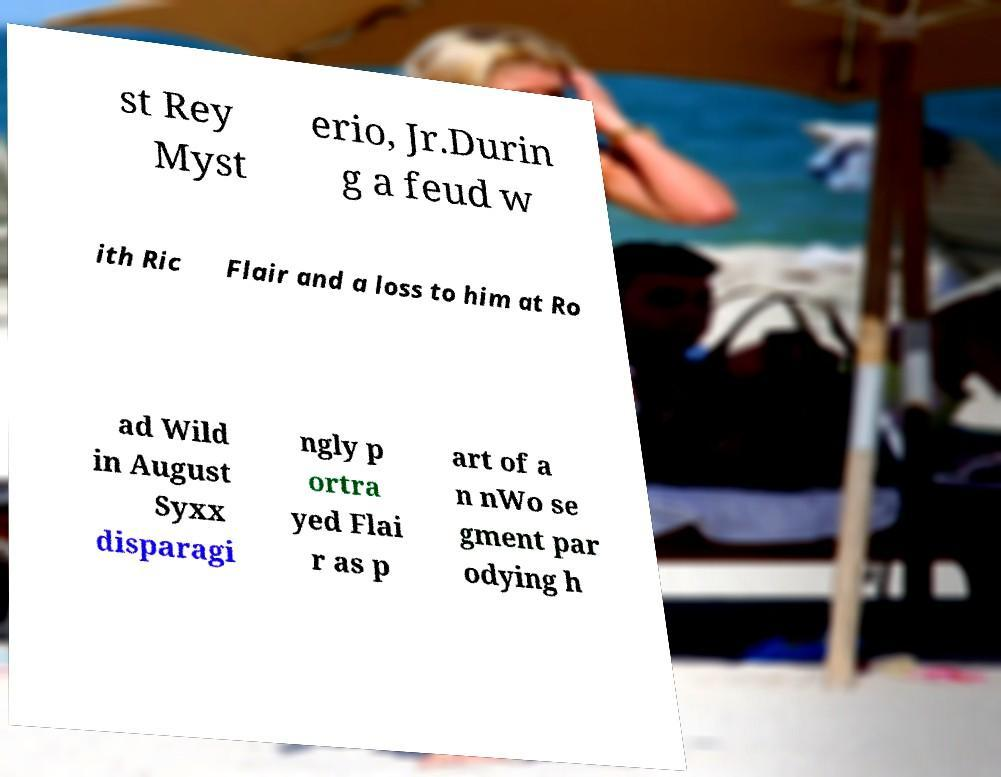Please read and relay the text visible in this image. What does it say? st Rey Myst erio, Jr.Durin g a feud w ith Ric Flair and a loss to him at Ro ad Wild in August Syxx disparagi ngly p ortra yed Flai r as p art of a n nWo se gment par odying h 